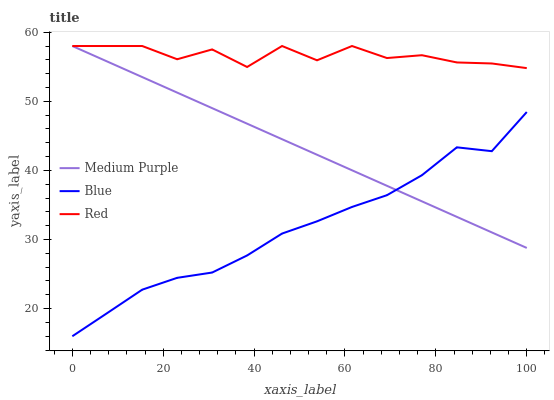Does Red have the minimum area under the curve?
Answer yes or no. No. Does Blue have the maximum area under the curve?
Answer yes or no. No. Is Blue the smoothest?
Answer yes or no. No. Is Blue the roughest?
Answer yes or no. No. Does Red have the lowest value?
Answer yes or no. No. Does Blue have the highest value?
Answer yes or no. No. Is Blue less than Red?
Answer yes or no. Yes. Is Red greater than Blue?
Answer yes or no. Yes. Does Blue intersect Red?
Answer yes or no. No. 